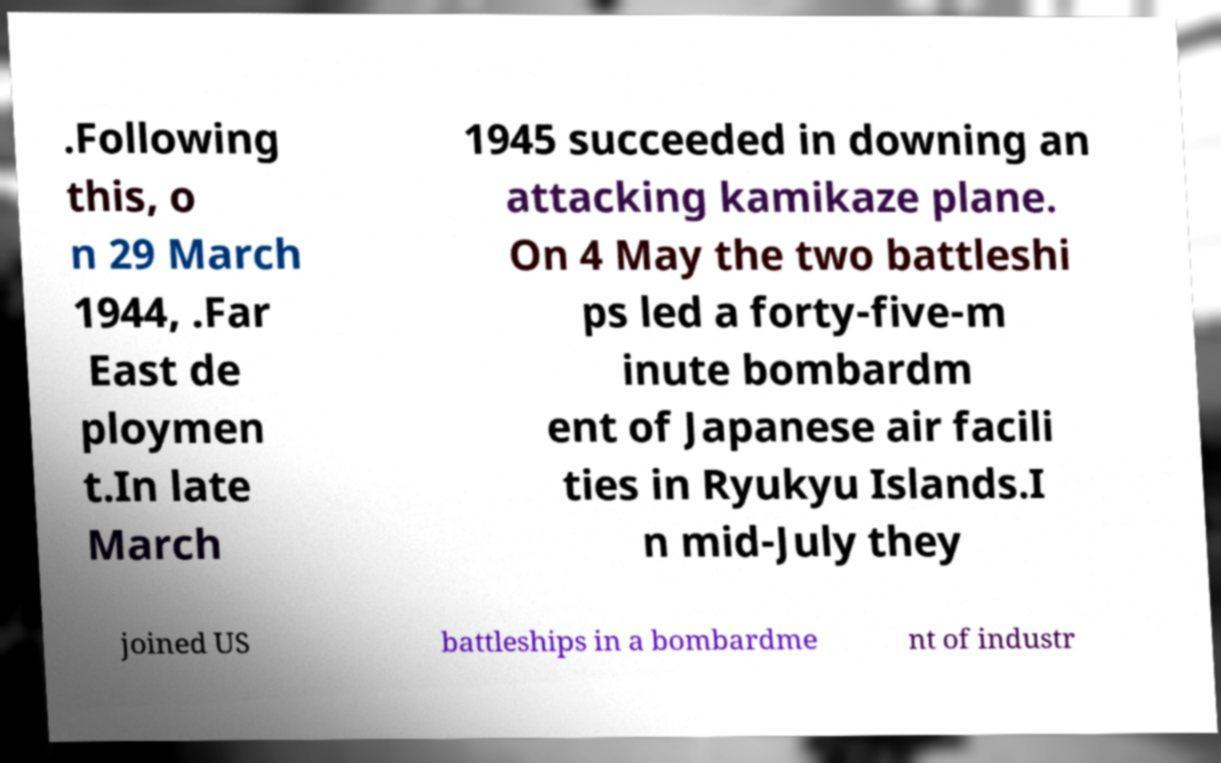I need the written content from this picture converted into text. Can you do that? .Following this, o n 29 March 1944, .Far East de ploymen t.In late March 1945 succeeded in downing an attacking kamikaze plane. On 4 May the two battleshi ps led a forty-five-m inute bombardm ent of Japanese air facili ties in Ryukyu Islands.I n mid-July they joined US battleships in a bombardme nt of industr 